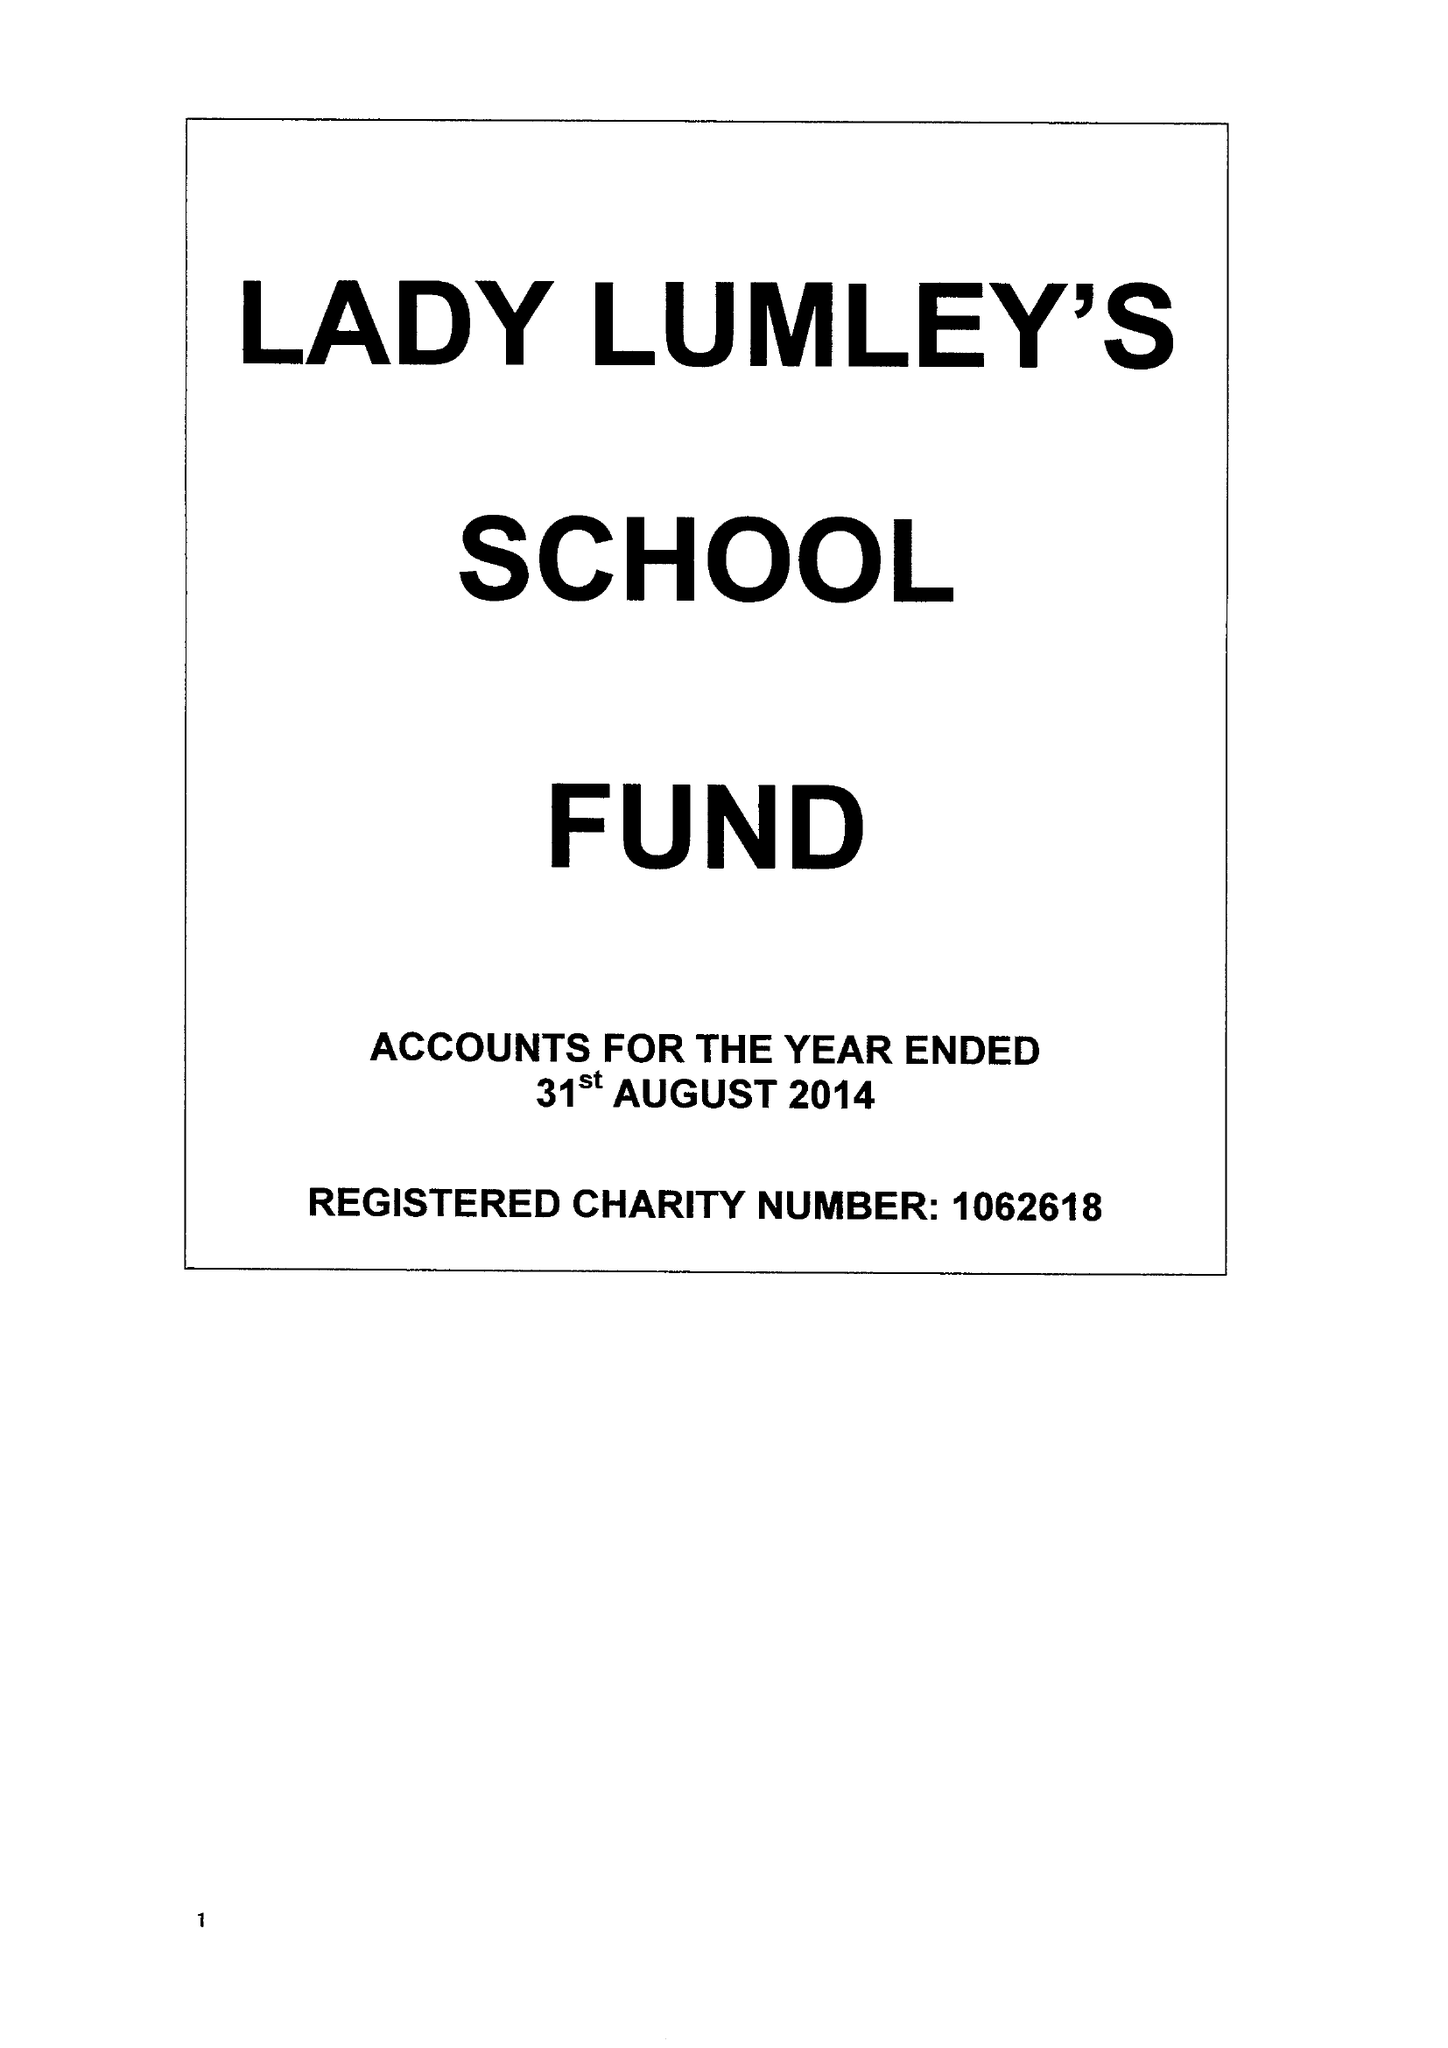What is the value for the charity_number?
Answer the question using a single word or phrase. 1062618 